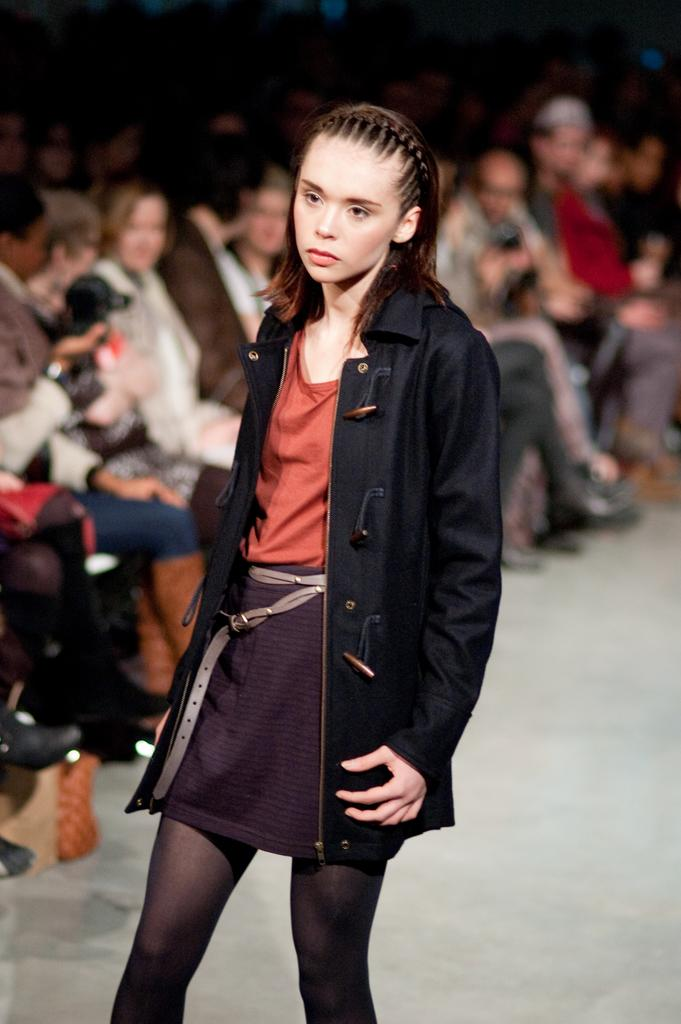What is the person in the image wearing? The person in the image is wearing a black coat. Can you describe the background of the image? The background of the image is blurred, but there are people sitting on chairs. What type of curtain can be seen in the image? There is no curtain present in the image. How does the stick affect the person wearing the black coat in the image? There is no stick present in the image, so it cannot affect the person wearing the black coat. 